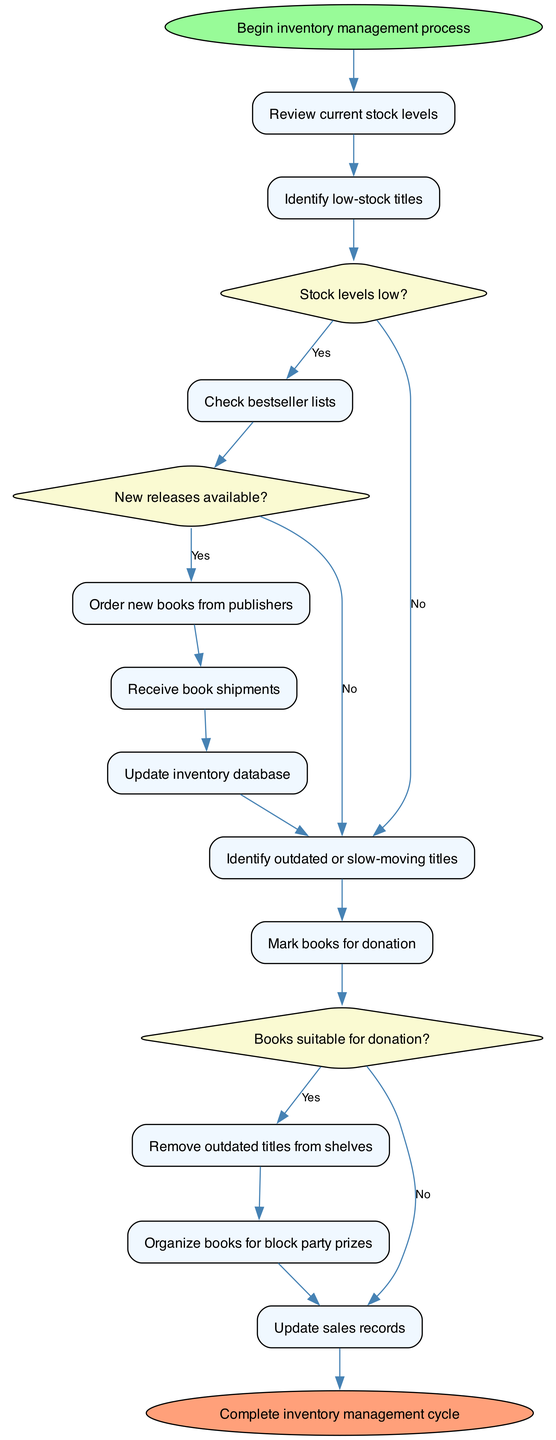What is the first activity in the inventory management process? The first activity listed in the diagram is "Review current stock levels," which is directly connected to the start node.
Answer: Review current stock levels How many decision nodes are present in the diagram? There are three decision nodes: "Stock levels low?", "New releases available?", and "Books suitable for donation?" Counting these gives us three decision points.
Answer: 3 What happens if the stock levels are low? If the stock levels are low, the flow goes from the "Identify low-stock titles" activity to the decision node "New releases available?", indicating that a check for new releases follows right after identifying low-stock items.
Answer: Check bestseller lists Which activity follows after the decision regarding new releases? After checking for new releases, if the answer is yes, the next activity is "Order new books from publishers." Thus, the flow indicates that ordering new books takes precedence if new releases are available.
Answer: Order new books from publishers What is the last activity before the end of the inventory management cycle? The last activity before reaching the end node is "Update sales records," which is connected to the final output of the management process.
Answer: Update sales records If books are suitable for donation, what is the immediate next activity? If the answer to "Books suitable for donation?" is yes, the next activity is "Mark books for donation," illustrating the process sequence involving donation suitability.
Answer: Mark books for donation What occurs after removing outdated titles from shelves? After the "Remove outdated titles from shelves" activity, the flow leads to organizing books for block party prizes, indicating a step to repurpose the removed books.
Answer: Organize books for block party prizes Which activity does not lead to a decision? The "Receive book shipments" activity is a straightforward action that doesn't lead to any decision node, indicating its direct nature in the process.
Answer: Receive book shipments 